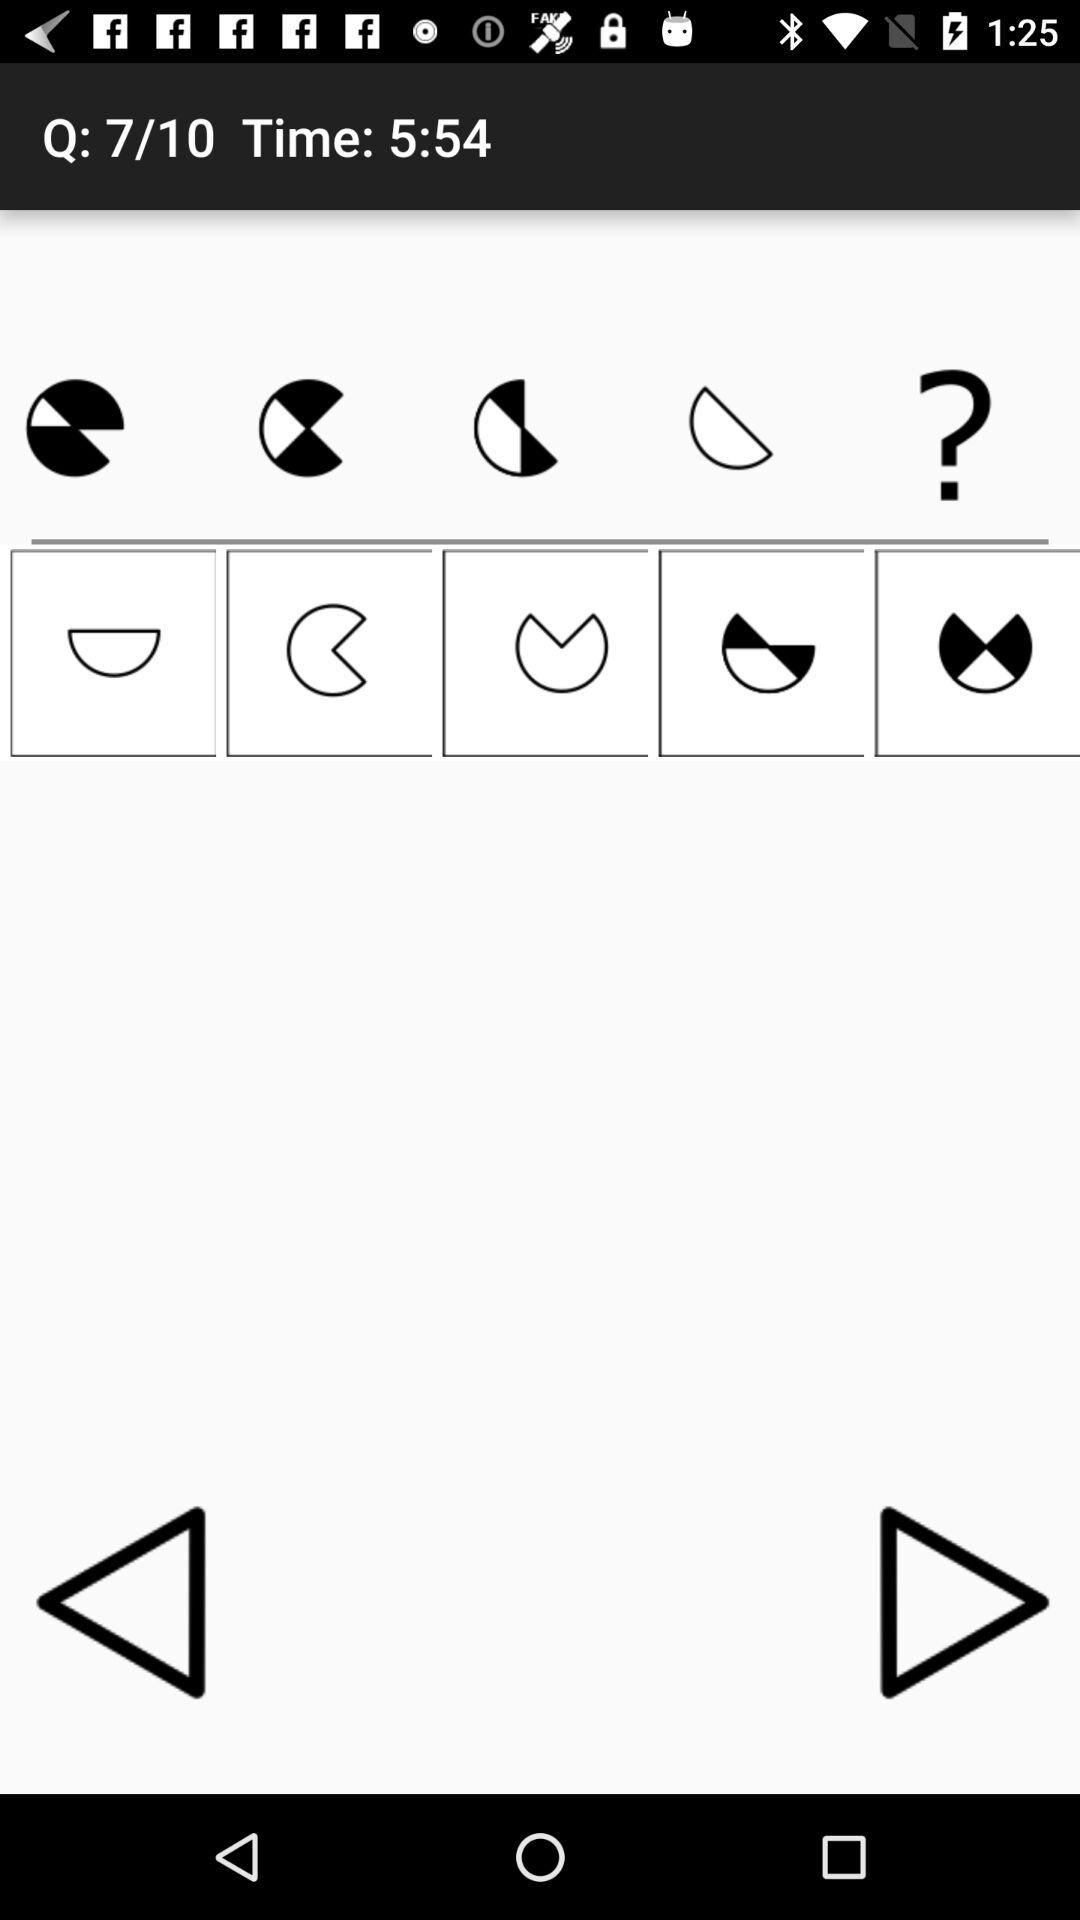What is the left time? The left time is 5 minutes 54 seconds. 